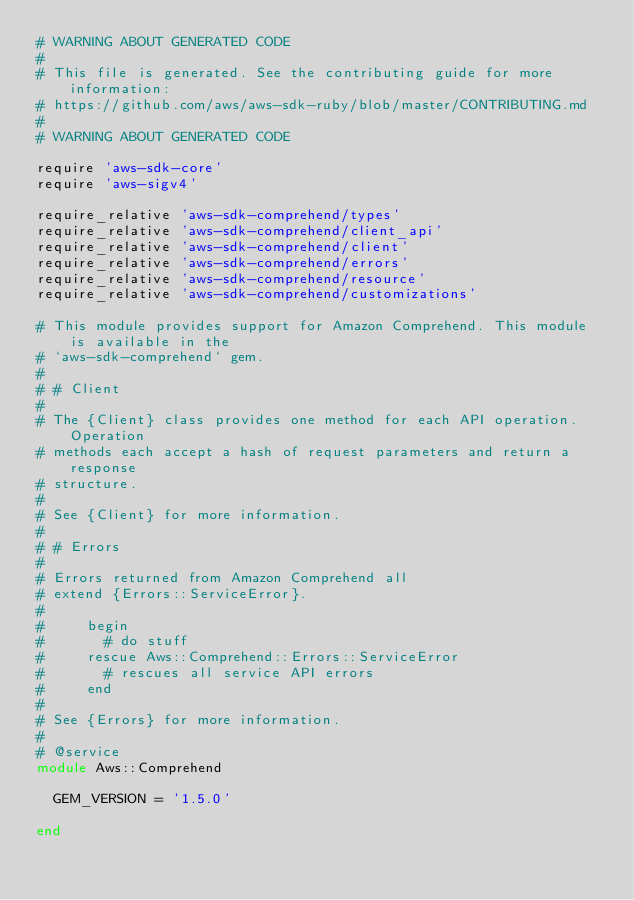<code> <loc_0><loc_0><loc_500><loc_500><_Ruby_># WARNING ABOUT GENERATED CODE
#
# This file is generated. See the contributing guide for more information:
# https://github.com/aws/aws-sdk-ruby/blob/master/CONTRIBUTING.md
#
# WARNING ABOUT GENERATED CODE

require 'aws-sdk-core'
require 'aws-sigv4'

require_relative 'aws-sdk-comprehend/types'
require_relative 'aws-sdk-comprehend/client_api'
require_relative 'aws-sdk-comprehend/client'
require_relative 'aws-sdk-comprehend/errors'
require_relative 'aws-sdk-comprehend/resource'
require_relative 'aws-sdk-comprehend/customizations'

# This module provides support for Amazon Comprehend. This module is available in the
# `aws-sdk-comprehend` gem.
#
# # Client
#
# The {Client} class provides one method for each API operation. Operation
# methods each accept a hash of request parameters and return a response
# structure.
#
# See {Client} for more information.
#
# # Errors
#
# Errors returned from Amazon Comprehend all
# extend {Errors::ServiceError}.
#
#     begin
#       # do stuff
#     rescue Aws::Comprehend::Errors::ServiceError
#       # rescues all service API errors
#     end
#
# See {Errors} for more information.
#
# @service
module Aws::Comprehend

  GEM_VERSION = '1.5.0'

end
</code> 